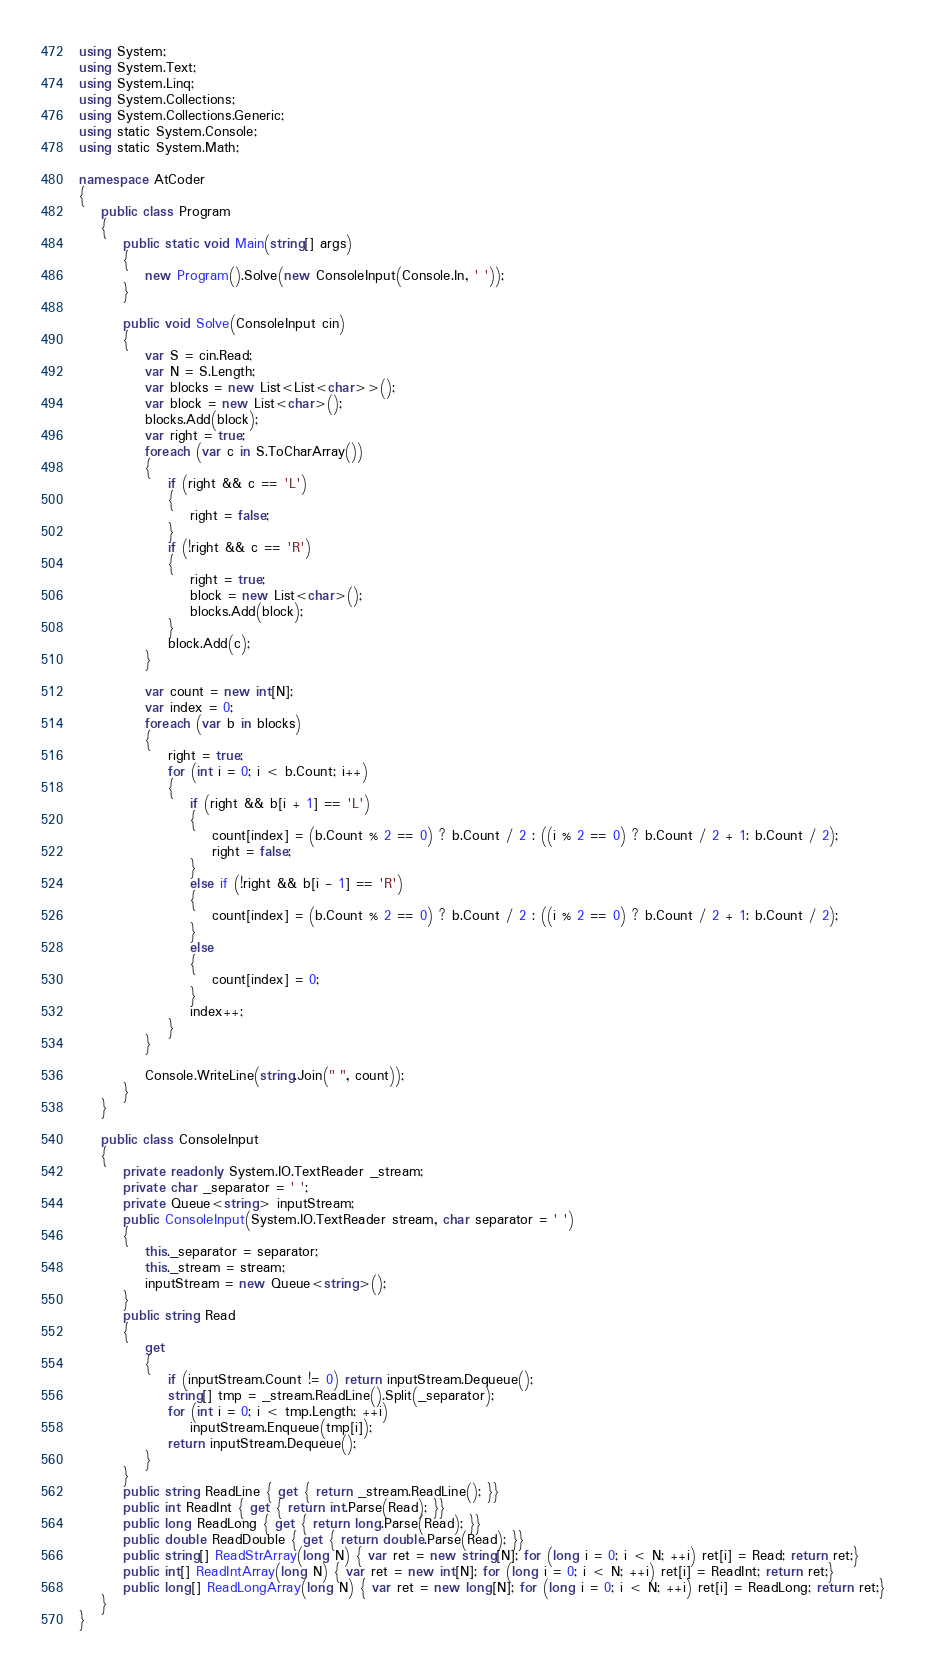<code> <loc_0><loc_0><loc_500><loc_500><_C#_>using System;
using System.Text;
using System.Linq;
using System.Collections;
using System.Collections.Generic;
using static System.Console;
using static System.Math;

namespace AtCoder
{
    public class Program
    {
        public static void Main(string[] args)
        {
            new Program().Solve(new ConsoleInput(Console.In, ' '));
        }

        public void Solve(ConsoleInput cin)
        {
            var S = cin.Read;
            var N = S.Length;
            var blocks = new List<List<char>>();
            var block = new List<char>();
            blocks.Add(block);
            var right = true;
            foreach (var c in S.ToCharArray())
            {
                if (right && c == 'L')
                {
                    right = false;
                }
                if (!right && c == 'R')
                {
                    right = true;
                    block = new List<char>();
                    blocks.Add(block);
                }
                block.Add(c);
            }

            var count = new int[N];
            var index = 0;
            foreach (var b in blocks)
            {
                right = true;
                for (int i = 0; i < b.Count; i++)
                {
                    if (right && b[i + 1] == 'L')
                    {
                        count[index] = (b.Count % 2 == 0) ? b.Count / 2 : ((i % 2 == 0) ? b.Count / 2 + 1: b.Count / 2);
                        right = false;
                    }
                    else if (!right && b[i - 1] == 'R')
                    {
                        count[index] = (b.Count % 2 == 0) ? b.Count / 2 : ((i % 2 == 0) ? b.Count / 2 + 1: b.Count / 2);
                    }
                    else
                    {
                        count[index] = 0;
                    }
                    index++;
                }
            }

            Console.WriteLine(string.Join(" ", count));
        }
    }

    public class ConsoleInput
    {
        private readonly System.IO.TextReader _stream;
        private char _separator = ' ';
        private Queue<string> inputStream;
        public ConsoleInput(System.IO.TextReader stream, char separator = ' ')
        {
            this._separator = separator;
            this._stream = stream;
            inputStream = new Queue<string>();
        }
        public string Read
        {
            get
            {
                if (inputStream.Count != 0) return inputStream.Dequeue();
                string[] tmp = _stream.ReadLine().Split(_separator);
                for (int i = 0; i < tmp.Length; ++i)
                    inputStream.Enqueue(tmp[i]);
                return inputStream.Dequeue();
            }
        }
        public string ReadLine { get { return _stream.ReadLine(); }}
        public int ReadInt { get { return int.Parse(Read); }}
        public long ReadLong { get { return long.Parse(Read); }}
        public double ReadDouble { get { return double.Parse(Read); }}
        public string[] ReadStrArray(long N) { var ret = new string[N]; for (long i = 0; i < N; ++i) ret[i] = Read; return ret;}
        public int[] ReadIntArray(long N) { var ret = new int[N]; for (long i = 0; i < N; ++i) ret[i] = ReadInt; return ret;}
        public long[] ReadLongArray(long N) { var ret = new long[N]; for (long i = 0; i < N; ++i) ret[i] = ReadLong; return ret;}
    }
}
</code> 